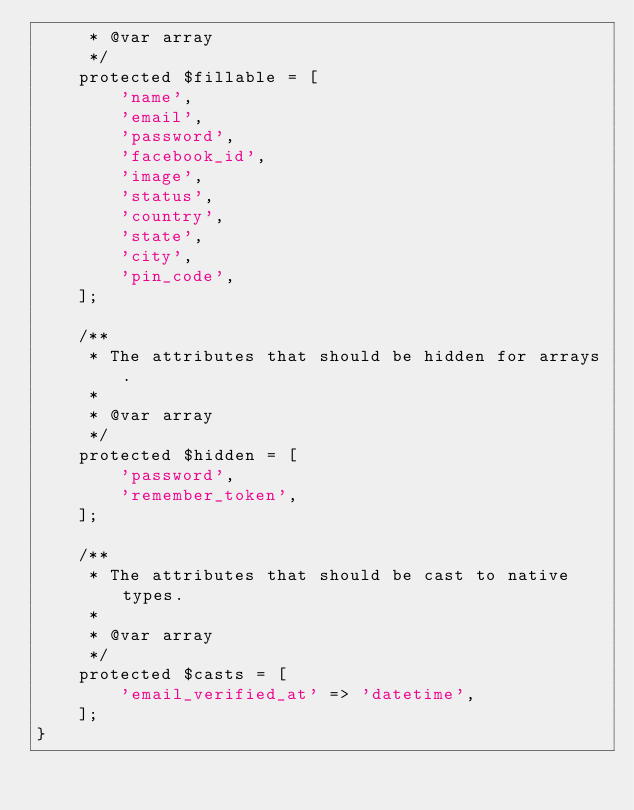Convert code to text. <code><loc_0><loc_0><loc_500><loc_500><_PHP_>     * @var array
     */
    protected $fillable = [
        'name',
        'email',
        'password',
        'facebook_id',
        'image',
        'status',
        'country',
        'state',
        'city',
        'pin_code',
    ];

    /**
     * The attributes that should be hidden for arrays.
     *
     * @var array
     */
    protected $hidden = [
        'password',
        'remember_token',
    ];

    /**
     * The attributes that should be cast to native types.
     *
     * @var array
     */
    protected $casts = [
        'email_verified_at' => 'datetime',
    ];
}
</code> 